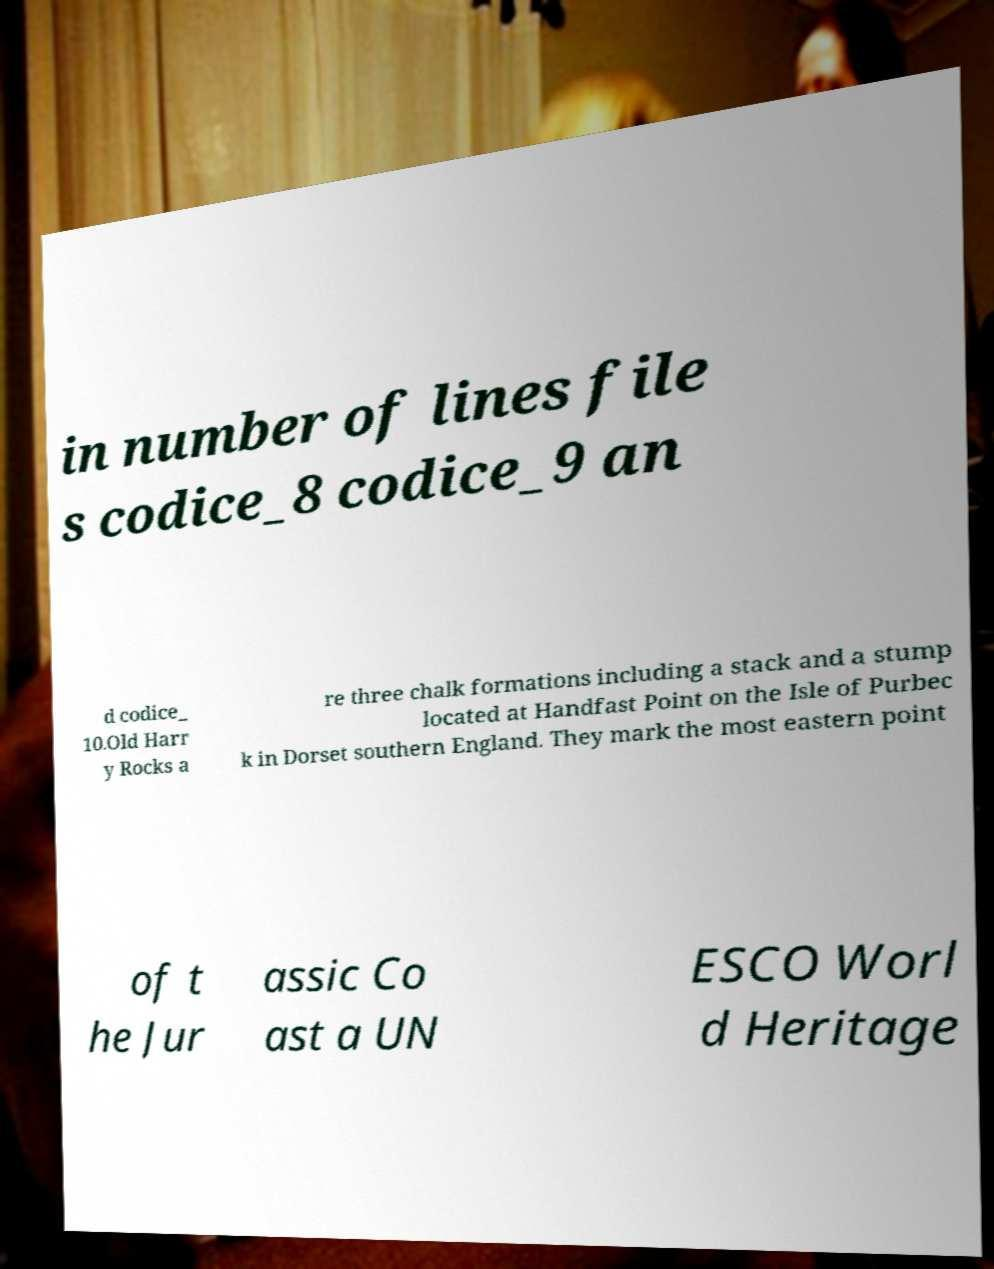Please read and relay the text visible in this image. What does it say? in number of lines file s codice_8 codice_9 an d codice_ 10.Old Harr y Rocks a re three chalk formations including a stack and a stump located at Handfast Point on the Isle of Purbec k in Dorset southern England. They mark the most eastern point of t he Jur assic Co ast a UN ESCO Worl d Heritage 